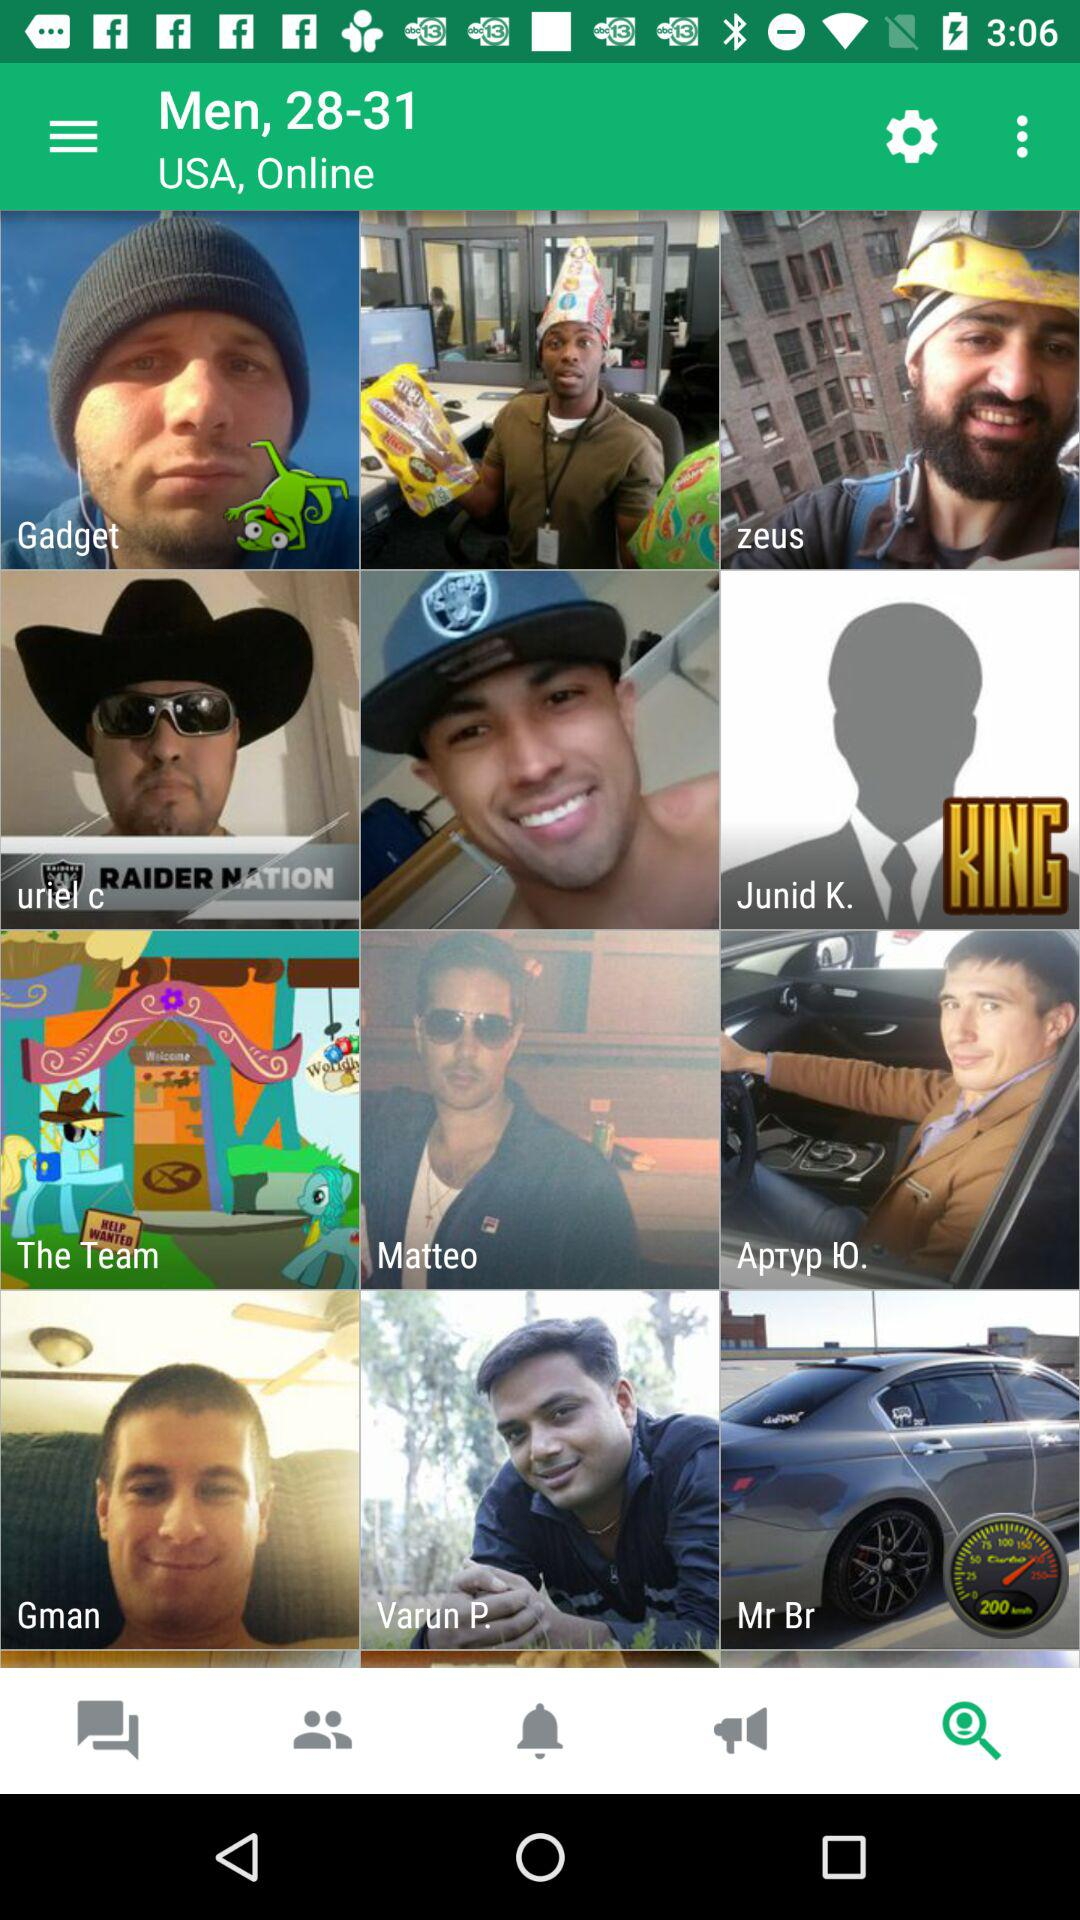What is the age limit? The age limit is from 28 years to 31 years. 